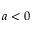Convert formula to latex. <formula><loc_0><loc_0><loc_500><loc_500>a < 0</formula> 